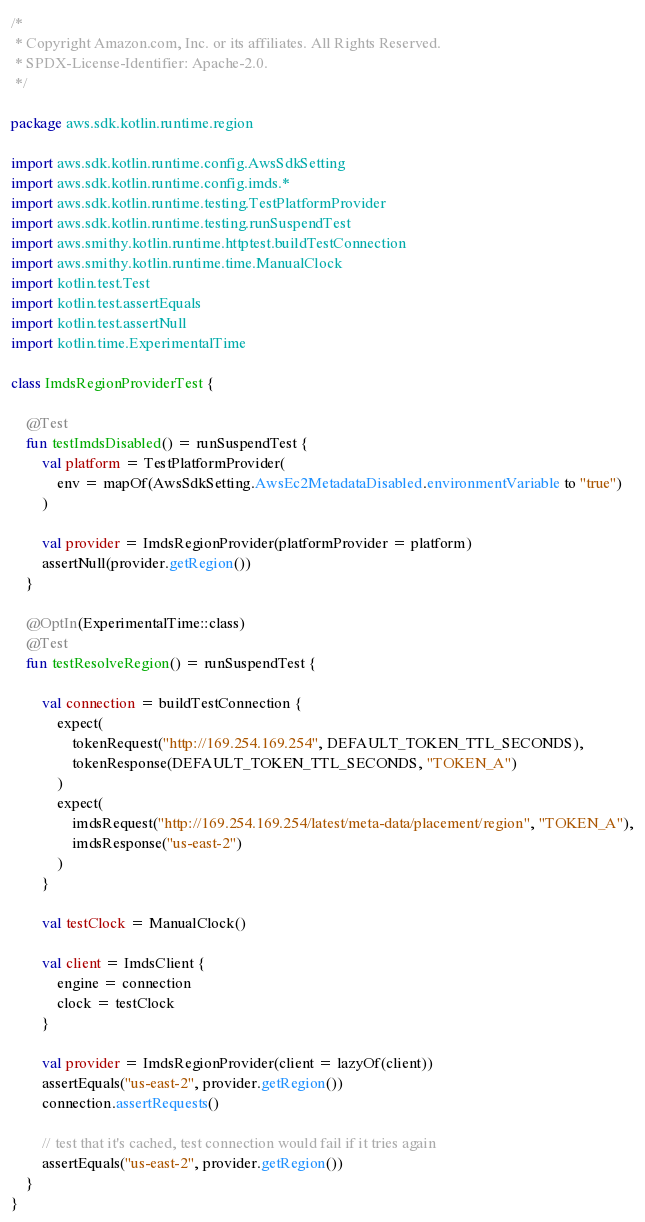Convert code to text. <code><loc_0><loc_0><loc_500><loc_500><_Kotlin_>/*
 * Copyright Amazon.com, Inc. or its affiliates. All Rights Reserved.
 * SPDX-License-Identifier: Apache-2.0.
 */

package aws.sdk.kotlin.runtime.region

import aws.sdk.kotlin.runtime.config.AwsSdkSetting
import aws.sdk.kotlin.runtime.config.imds.*
import aws.sdk.kotlin.runtime.testing.TestPlatformProvider
import aws.sdk.kotlin.runtime.testing.runSuspendTest
import aws.smithy.kotlin.runtime.httptest.buildTestConnection
import aws.smithy.kotlin.runtime.time.ManualClock
import kotlin.test.Test
import kotlin.test.assertEquals
import kotlin.test.assertNull
import kotlin.time.ExperimentalTime

class ImdsRegionProviderTest {

    @Test
    fun testImdsDisabled() = runSuspendTest {
        val platform = TestPlatformProvider(
            env = mapOf(AwsSdkSetting.AwsEc2MetadataDisabled.environmentVariable to "true")
        )

        val provider = ImdsRegionProvider(platformProvider = platform)
        assertNull(provider.getRegion())
    }

    @OptIn(ExperimentalTime::class)
    @Test
    fun testResolveRegion() = runSuspendTest {

        val connection = buildTestConnection {
            expect(
                tokenRequest("http://169.254.169.254", DEFAULT_TOKEN_TTL_SECONDS),
                tokenResponse(DEFAULT_TOKEN_TTL_SECONDS, "TOKEN_A")
            )
            expect(
                imdsRequest("http://169.254.169.254/latest/meta-data/placement/region", "TOKEN_A"),
                imdsResponse("us-east-2")
            )
        }

        val testClock = ManualClock()

        val client = ImdsClient {
            engine = connection
            clock = testClock
        }

        val provider = ImdsRegionProvider(client = lazyOf(client))
        assertEquals("us-east-2", provider.getRegion())
        connection.assertRequests()

        // test that it's cached, test connection would fail if it tries again
        assertEquals("us-east-2", provider.getRegion())
    }
}
</code> 